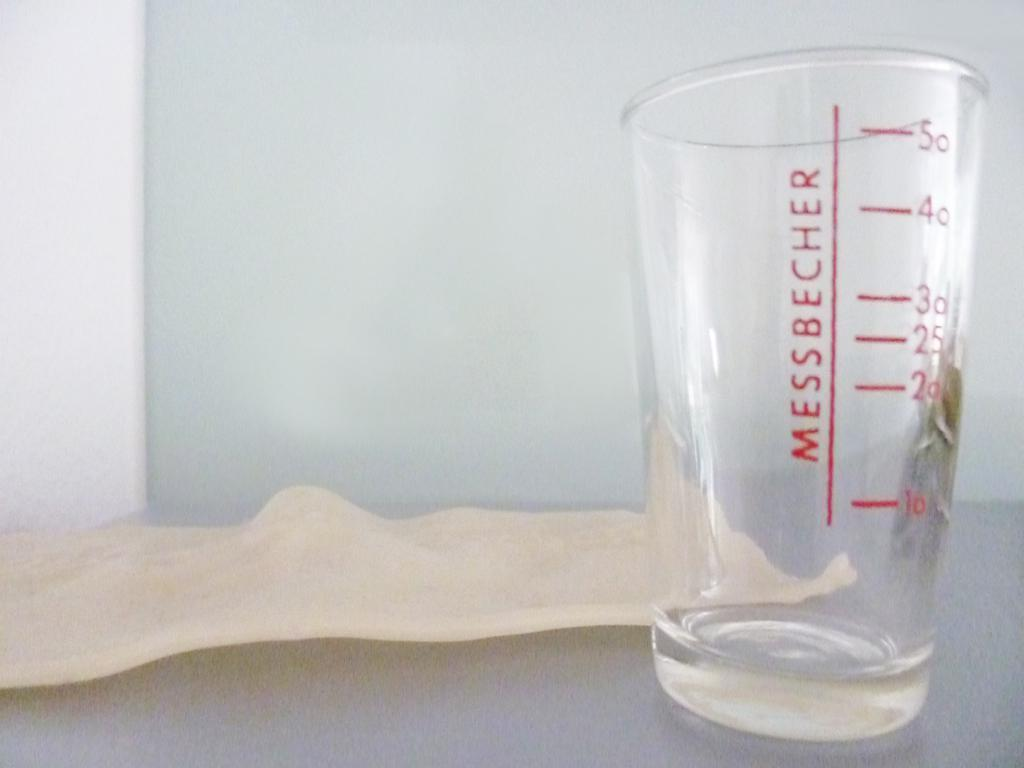<image>
Provide a brief description of the given image. A large glass with measuring lines on it and says Messbecher. 